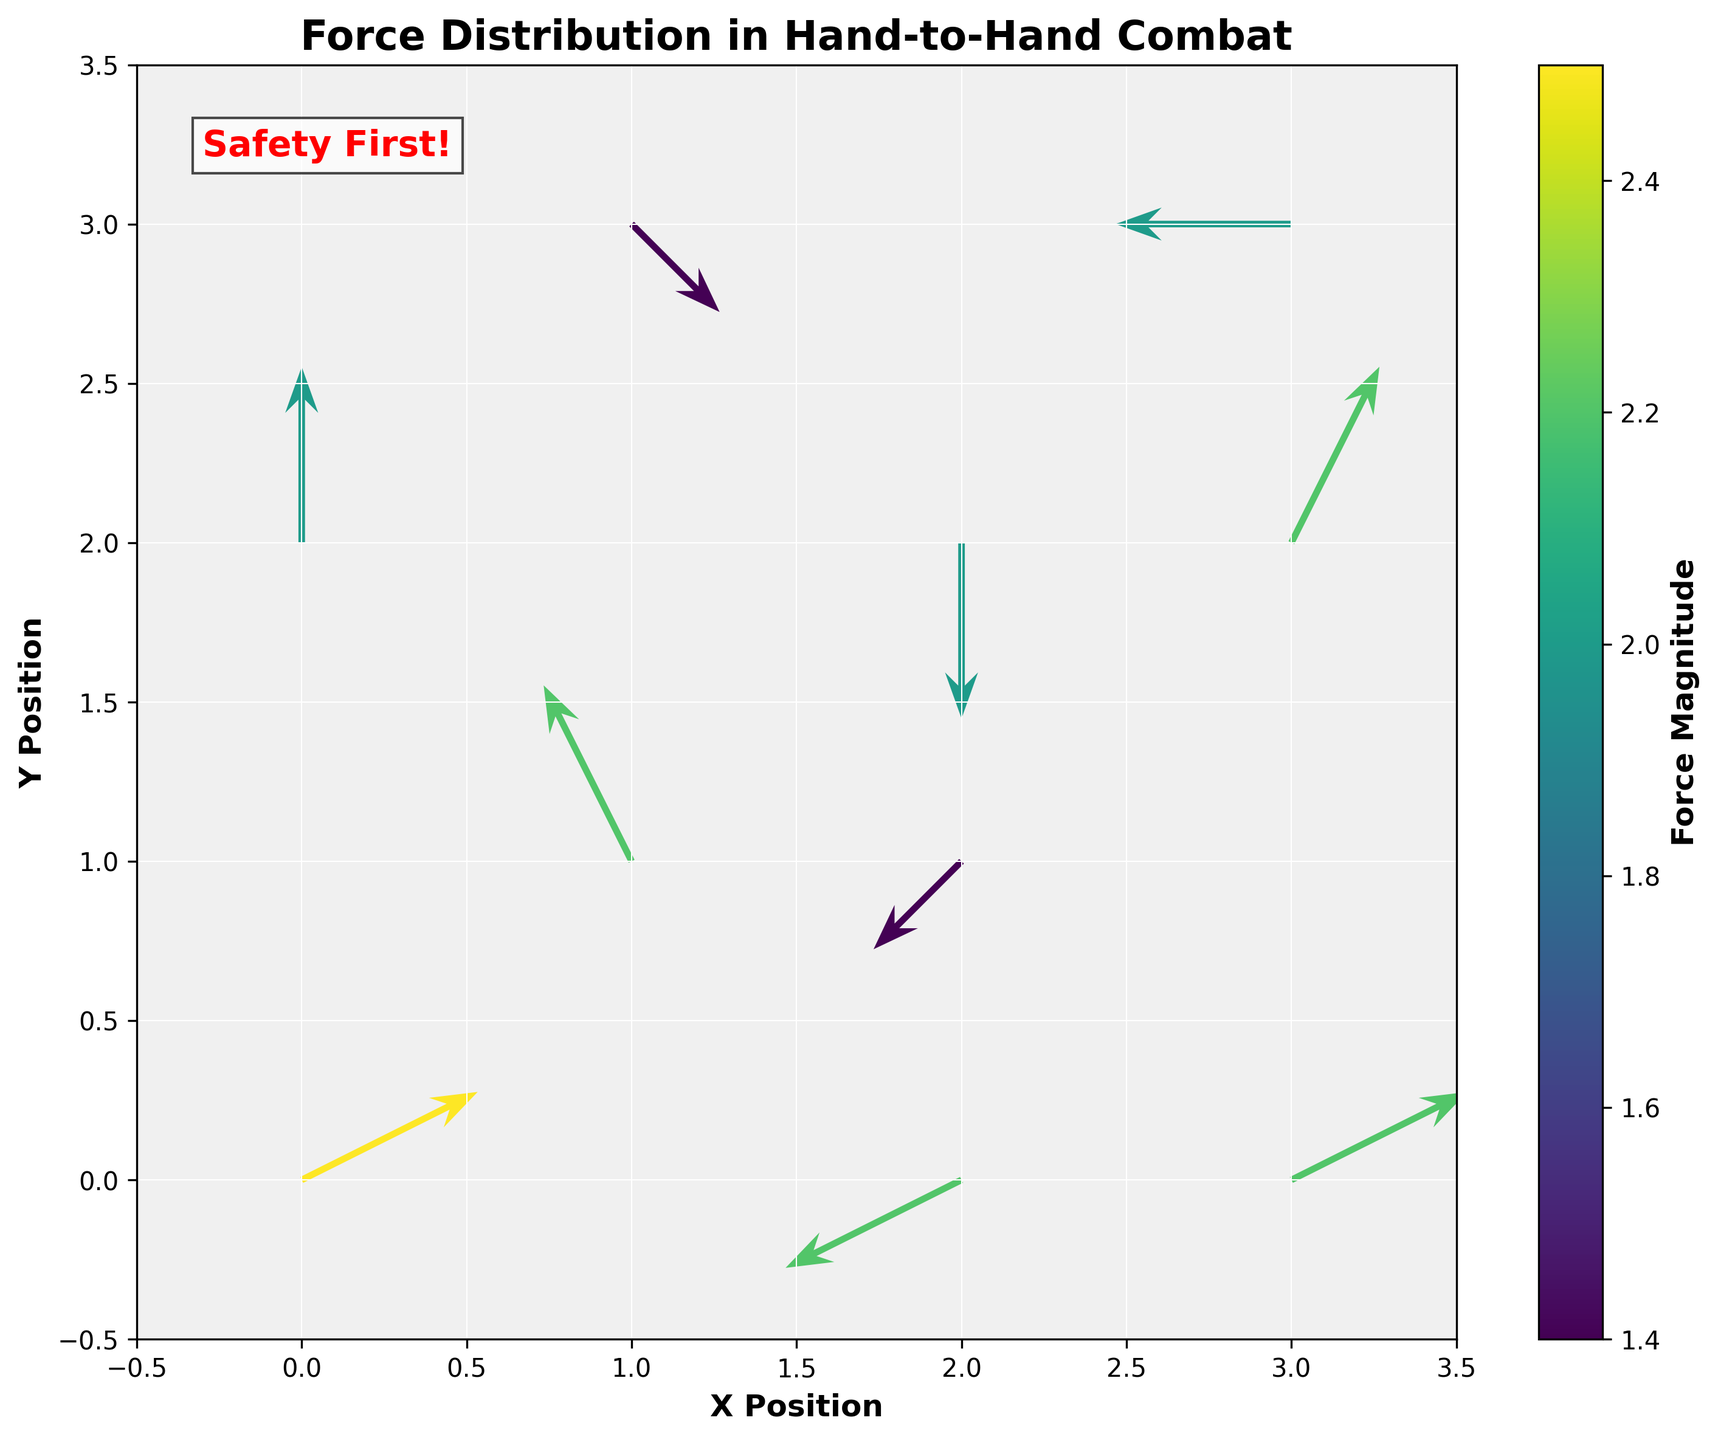What is the title of the plot? The title of the plot is usually found at the top and provides an overview of the figure. In this case, the title is clearly stated at the top of the plot.
Answer: Force Distribution in Hand-to-Hand Combat What are the x and y limits of the plot? The axis limits define the range of values displayed on the plot. By looking at the ends of both axes, you can see the lower and upper limits for both.
Answer: x: -0.5 to 3.5, y: -0.5 to 3.5 How many vectors are shown in the plot? Each vector represents a point with a corresponding arrow. By counting the arrows, you can determine the total number of vectors.
Answer: 10 Which vector has the highest magnitude, and where is it located on the plot? Magnitude is shown using color intensity in the plot. The vector with the darkest (or most intense) color indicates the highest magnitude. By identifying this vector and noting its x, y coordinates, you can determine its location. According to the data, the vector with the highest magnitude is 2.5 at (0, 0).
Answer: (0, 0) Which vector is directed upwards? The direction of a vector can be determined by the orientation of the arrow. An upward arrow has a positive v component. By looking at the orientation and matching it to the data's positive v values, you can identify the vectors directed upwards. Several vectors have upward orientation: (1, 1), (0, 2), and (3, 2).
Answer: (1, 1), (0, 2), and (3, 2) What is the color of the vectors representing the smallest magnitudes? In a quiver plot, the color bar indicates the magnitude of the vectors. Lighter colors on the color scale typically represent smaller magnitudes.
Answer: Light yellow What’s the approximate average magnitude of the vectors situated at y=0? To calculate the average of these vectors, you need to find all vectors with y=0, sum their magnitudes, and divide by the number of vectors. According to the data, the magnitudes at y=0 are 2.5 (0, 0), 2.2 (3, 0), and 2.2 (2, 0). Adding these, we get 2.5 + 2.2 + 2.2 = 6.9, and dividing by 3, we obtain 6.9/3 = 2.3.
Answer: 2.3 Which direction does the vector at (1, 3) point to, and what can this indicate in a self-defense scenario? By checking the data, you can find that the vector at (1, 3) has u=1 and v=-1, indicating a diagonal downward right direction. This suggests a force moving slightly towards the center but downwards. In a self-defense situation, this could represent a motion to deflect or redirect an attack.
Answer: Downward right, potentially to deflect an attack What is the difference in the magnitude of the vectors at (3, 3) and (2, 2)? By comparing the magnitudes at these coordinates, you can find their difference. According to the data, at (3, 3) the magnitude is 2.0, and at (2, 2) it is 2.0. Thus, the difference is 2.0 - 2.0.
Answer: 0.0 Which vectors have a purely horizontal component, and what does this signify? A purely horizontal vector has no vertical component, meaning v=0. Checking the data, we find vectors: (2, 2), (3, 3), and (2, 0). Purely horizontal components typically signify lateral movements or pushes in a self-defense scenario.
Answer: (2, 2), (3, 3), and (2, 0) What is the significance of the annotation “Safety First!” in the context of this plot? The annotation "Safety First!" emphasizes the importance of prioritizing personal safety, possibly hinting at the goal of self-defense training to avoid harm. This aligns well with the context of the plot, which visually represents movements designed to protect or defend oneself.
Answer: Emphasizes the importance of personal safety in self-defense situations 